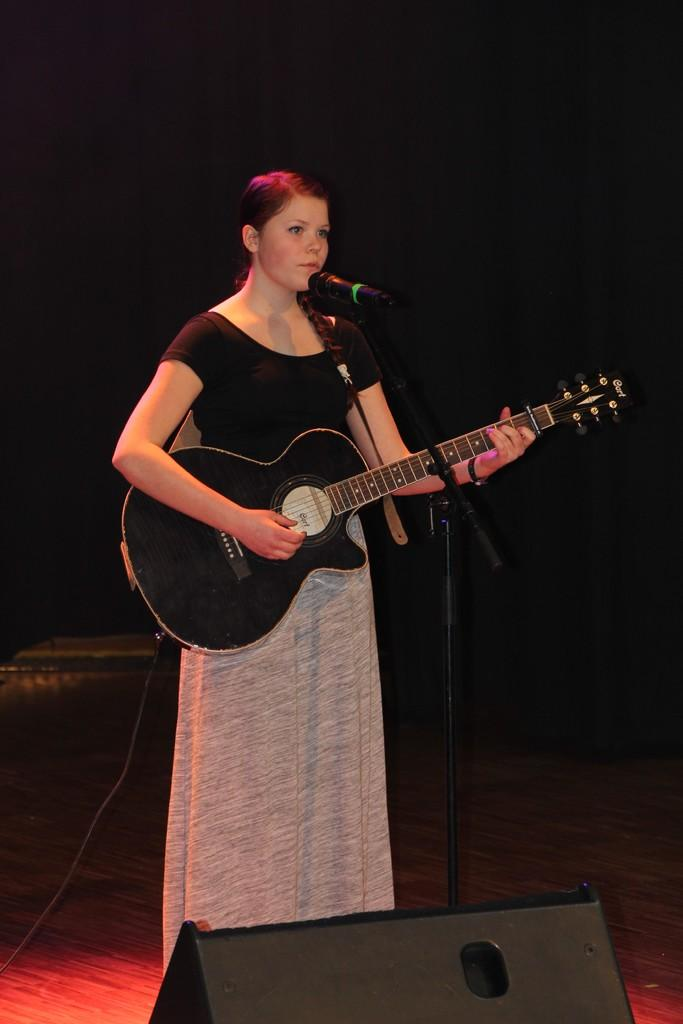Who is the main subject in the image? There is a woman in the image. What is the woman doing in the image? The woman is standing, playing a guitar, and singing into a microphone. What type of credit card is the woman using in the image? There is no credit card present in the image. Can you tell me where the woman is standing in the image? The woman is standing in the image, as mentioned in the provided facts. 